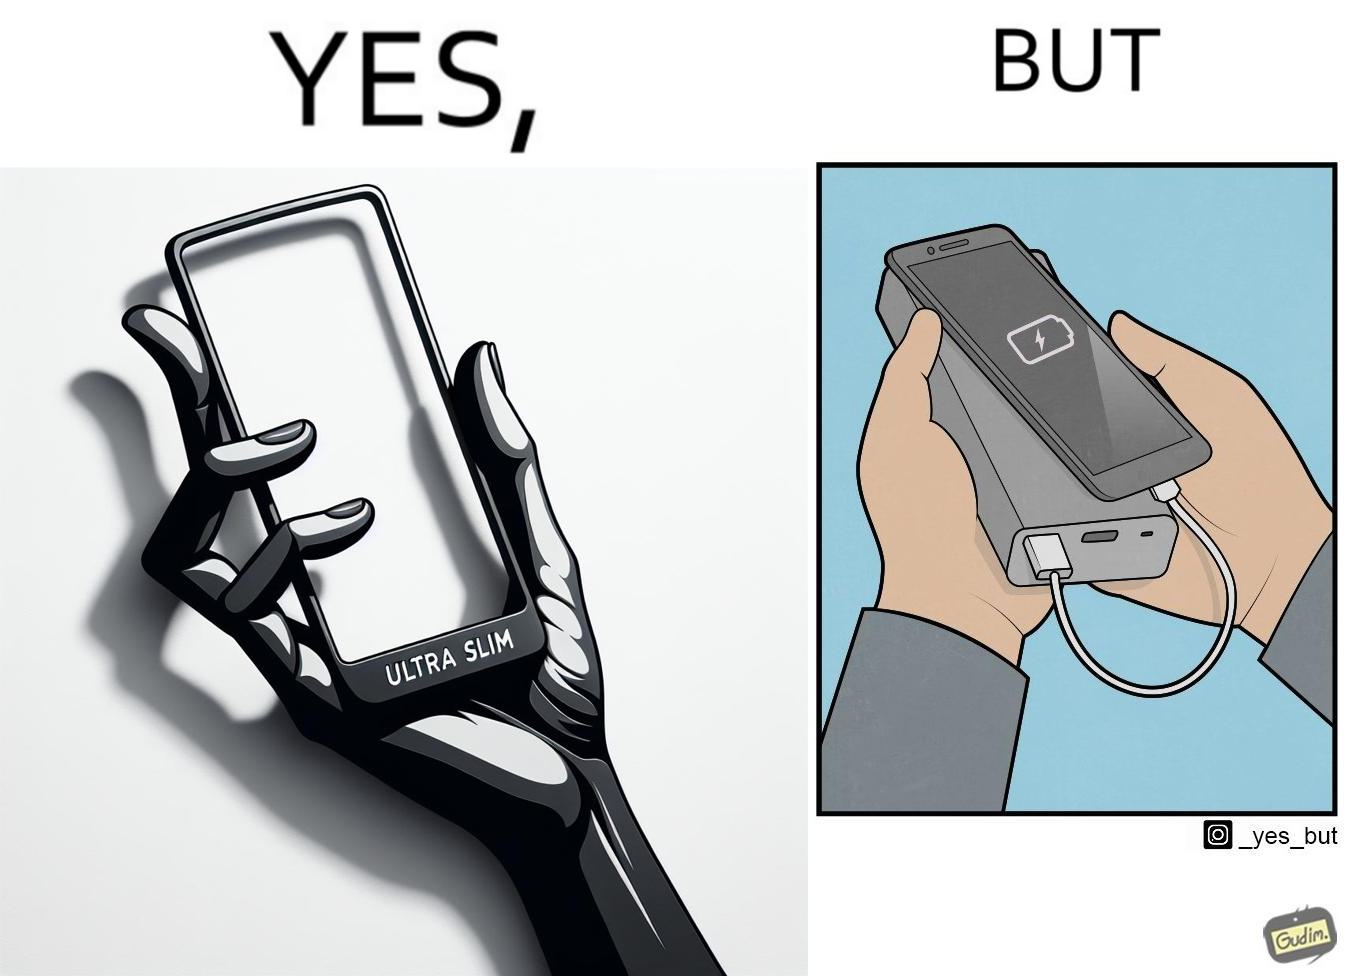Why is this image considered satirical? The image is satirical because even though the mobile phone has been developed to be very slim, it requires frequent recharging which makes the mobile phone useless without a big, heavy and thick power bank. 